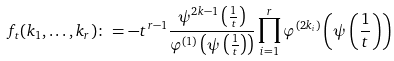<formula> <loc_0><loc_0><loc_500><loc_500>f _ { t } ( k _ { 1 } , \dots , k _ { r } ) \colon = - t ^ { r - 1 } \frac { \psi ^ { 2 k - 1 } \left ( \frac { 1 } { t } \right ) } { \varphi ^ { ( 1 ) } \left ( \psi \left ( \frac { 1 } { t } \right ) \right ) } \prod _ { i = 1 } ^ { r } \varphi ^ { ( 2 k _ { i } ) } \left ( \psi \left ( \frac { 1 } { t } \right ) \right )</formula> 